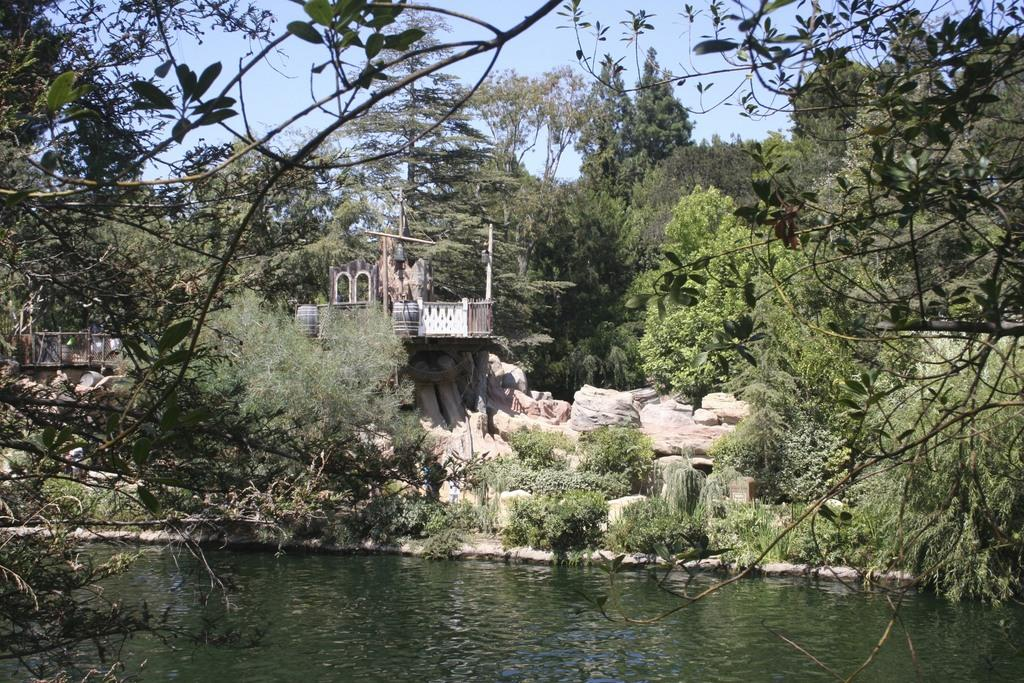What type of natural elements can be seen in the image? There are trees and water visible in the image. What type of man-made structure is present in the image? There is a building in the image. What type of barrier can be seen in the image? There is a fence in the image. What type of material is present in the image? There are stones in the image. What is visible at the top of the image? The sky is visible at the top of the image. How many letters are visible on the stones in the image? There are no letters visible on the stones in the image. What type of nut can be seen growing on the trees in the image? There are no nuts visible on the trees in the image. 